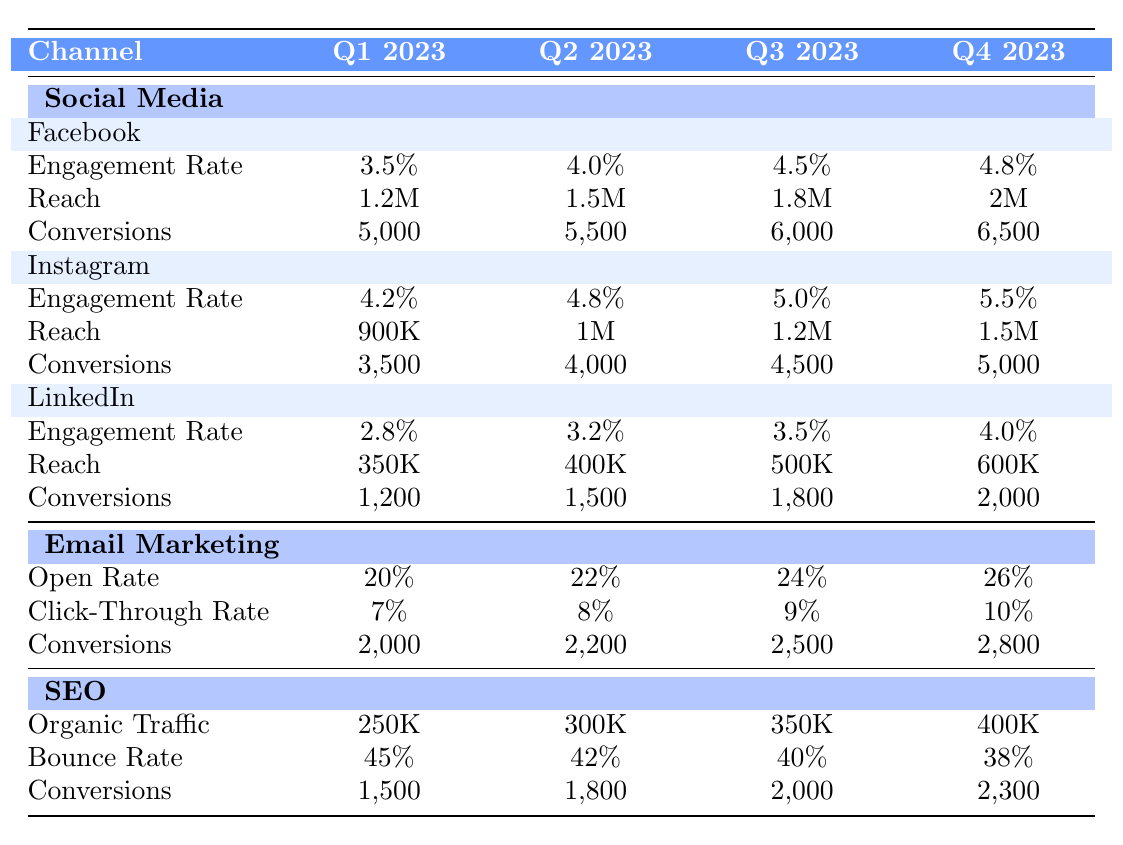What was the Engagement Rate for Instagram in Q2 2023? According to the table, the Engagement Rate for Instagram in Q2 2023 is listed as 4.8%.
Answer: 4.8% Which channel had the highest conversions in Q4 2023? By examining the conversion numbers for each channel in Q4 2023, Social Media (Facebook) recorded 6,500 conversions which is the highest among all listed channels.
Answer: Social Media (Facebook) with 6,500 conversions How much did the Open Rate increase from Q1 to Q4 in Email Marketing? The Open Rate in Q1 was 20%, and in Q4 it was 26%. To find the increase, we subtract 20% from 26%, which results in a 6% increase.
Answer: 6% Did the Bounce Rate in SEO decrease throughout 2023? The Bounce Rates for SEO are 45%, 42%, 40%, and 38% for Q1, Q2, Q3, and Q4 respectively. These values show a consistent decrease from Q1 to Q4, confirming that the Bounce Rate did indeed decrease throughout the year.
Answer: Yes What is the total number of Conversions for Facebook over all four quarters? By summing the conversions for Facebook in each quarter: 5,000 (Q1) + 5,500 (Q2) + 6,000 (Q3) + 6,500 (Q4) gives us a total of 23,000 conversions for the year.
Answer: 23,000 